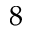<formula> <loc_0><loc_0><loc_500><loc_500>8</formula> 